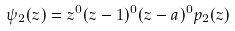<formula> <loc_0><loc_0><loc_500><loc_500>\psi _ { 2 } ( z ) = z ^ { 0 } ( z - 1 ) ^ { 0 } ( z - a ) ^ { 0 } p _ { 2 } ( z )</formula> 